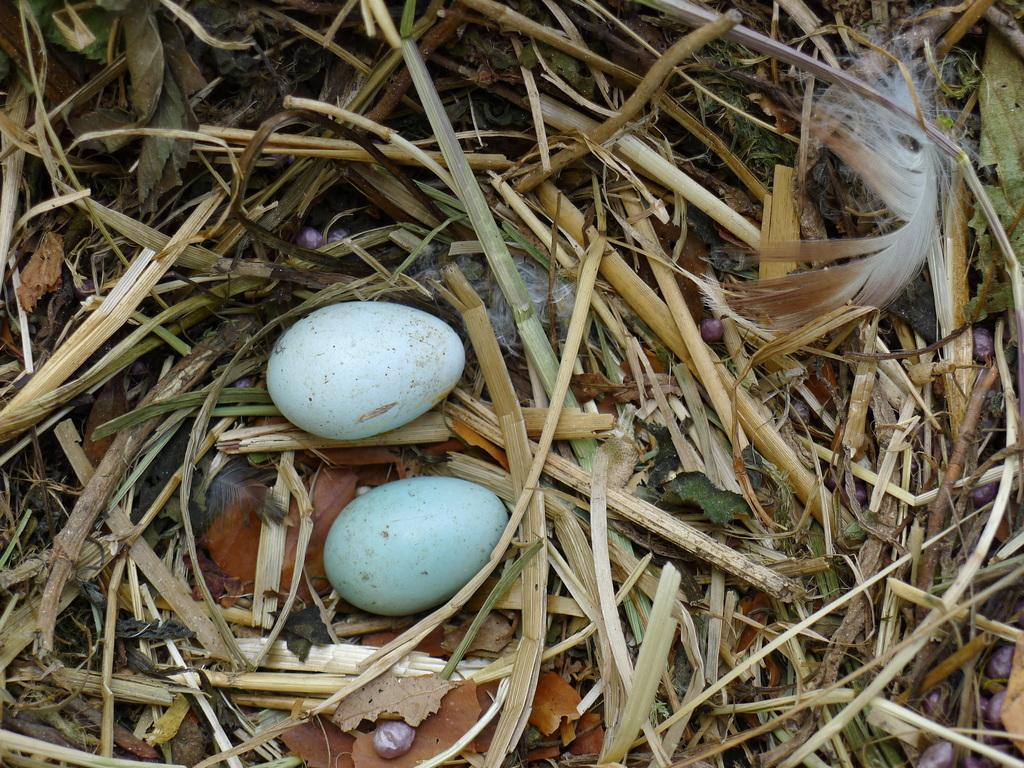What is present in the nest in the image? There are eggs in the nest. What else can be seen in the nest besides the eggs? There is a feather in the nest. What type of pollution is visible in the image? There is no pollution visible in the image; it features a nest with eggs and a feather. What type of soup is being prepared in the image? There is no soup or cooking activity present in the image. 